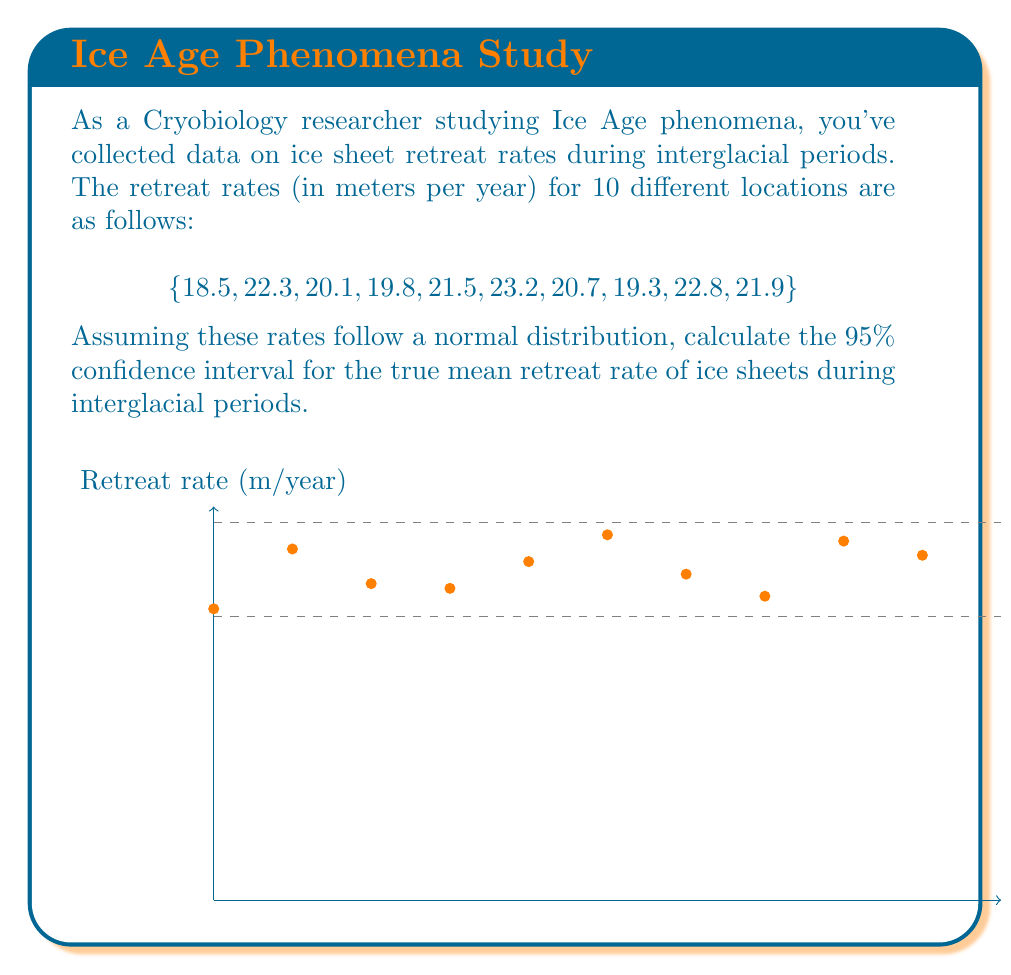Can you solve this math problem? To calculate the 95% confidence interval for the true mean retreat rate, we'll follow these steps:

1. Calculate the sample mean ($\bar{x}$):
   $$ \bar{x} = \frac{\sum_{i=1}^{n} x_i}{n} = \frac{18.5 + 22.3 + 20.1 + 19.8 + 21.5 + 23.2 + 20.7 + 19.3 + 22.8 + 21.9}{10} = 21.01 $$

2. Calculate the sample standard deviation ($s$):
   $$ s = \sqrt{\frac{\sum_{i=1}^{n} (x_i - \bar{x})^2}{n-1}} = 1.5846 $$

3. Determine the t-value for a 95% confidence interval with 9 degrees of freedom (n-1):
   $t_{0.025, 9} = 2.262$ (from t-distribution table)

4. Calculate the margin of error:
   $$ \text{Margin of Error} = t_{0.025, 9} \cdot \frac{s}{\sqrt{n}} = 2.262 \cdot \frac{1.5846}{\sqrt{10}} = 1.1323 $$

5. Compute the confidence interval:
   $$ \text{CI} = \bar{x} \pm \text{Margin of Error} $$
   $$ \text{CI} = 21.01 \pm 1.1323 $$
   $$ \text{CI} = (19.8777, 22.1423) $$

Therefore, we can be 95% confident that the true mean retreat rate of ice sheets during interglacial periods falls between 19.8777 and 22.1423 meters per year.
Answer: (19.8777, 22.1423) meters/year 